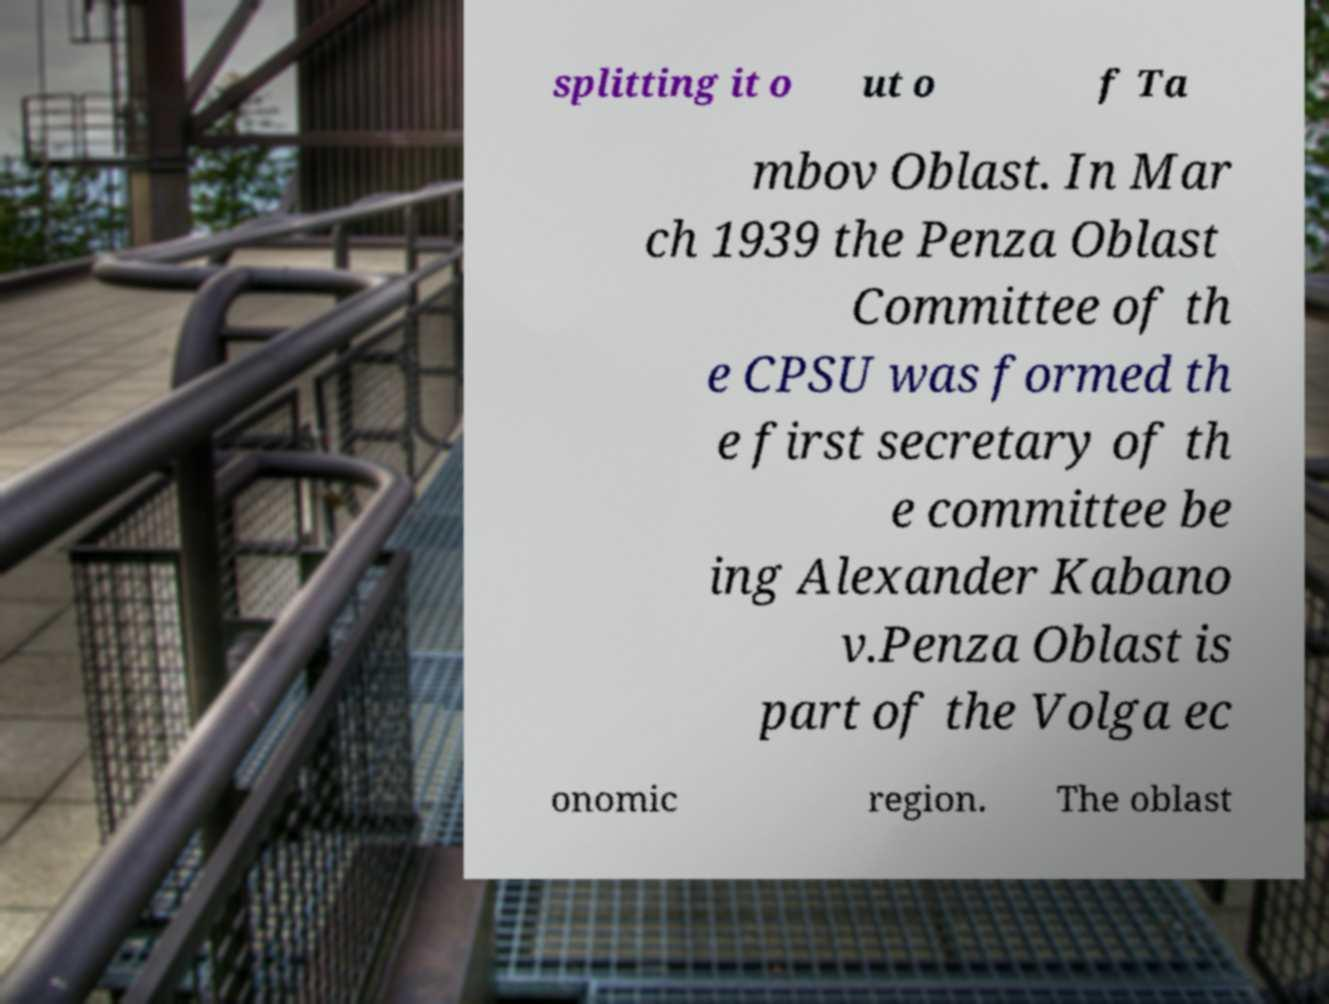Can you accurately transcribe the text from the provided image for me? splitting it o ut o f Ta mbov Oblast. In Mar ch 1939 the Penza Oblast Committee of th e CPSU was formed th e first secretary of th e committee be ing Alexander Kabano v.Penza Oblast is part of the Volga ec onomic region. The oblast 